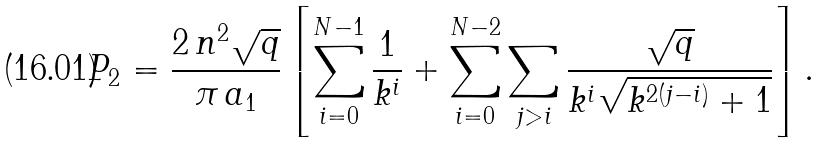Convert formula to latex. <formula><loc_0><loc_0><loc_500><loc_500>P _ { 2 } = \frac { 2 \, n ^ { 2 } \sqrt { q } } { \pi \, a _ { 1 } } \left [ \sum _ { i = 0 } ^ { N - 1 } \frac { 1 } { k ^ { i } } + \sum _ { i = 0 } ^ { N - 2 } \sum _ { j > i } \frac { \sqrt { q } } { k ^ { i } \sqrt { k ^ { 2 ( j - i ) } + 1 } } \right ] .</formula> 